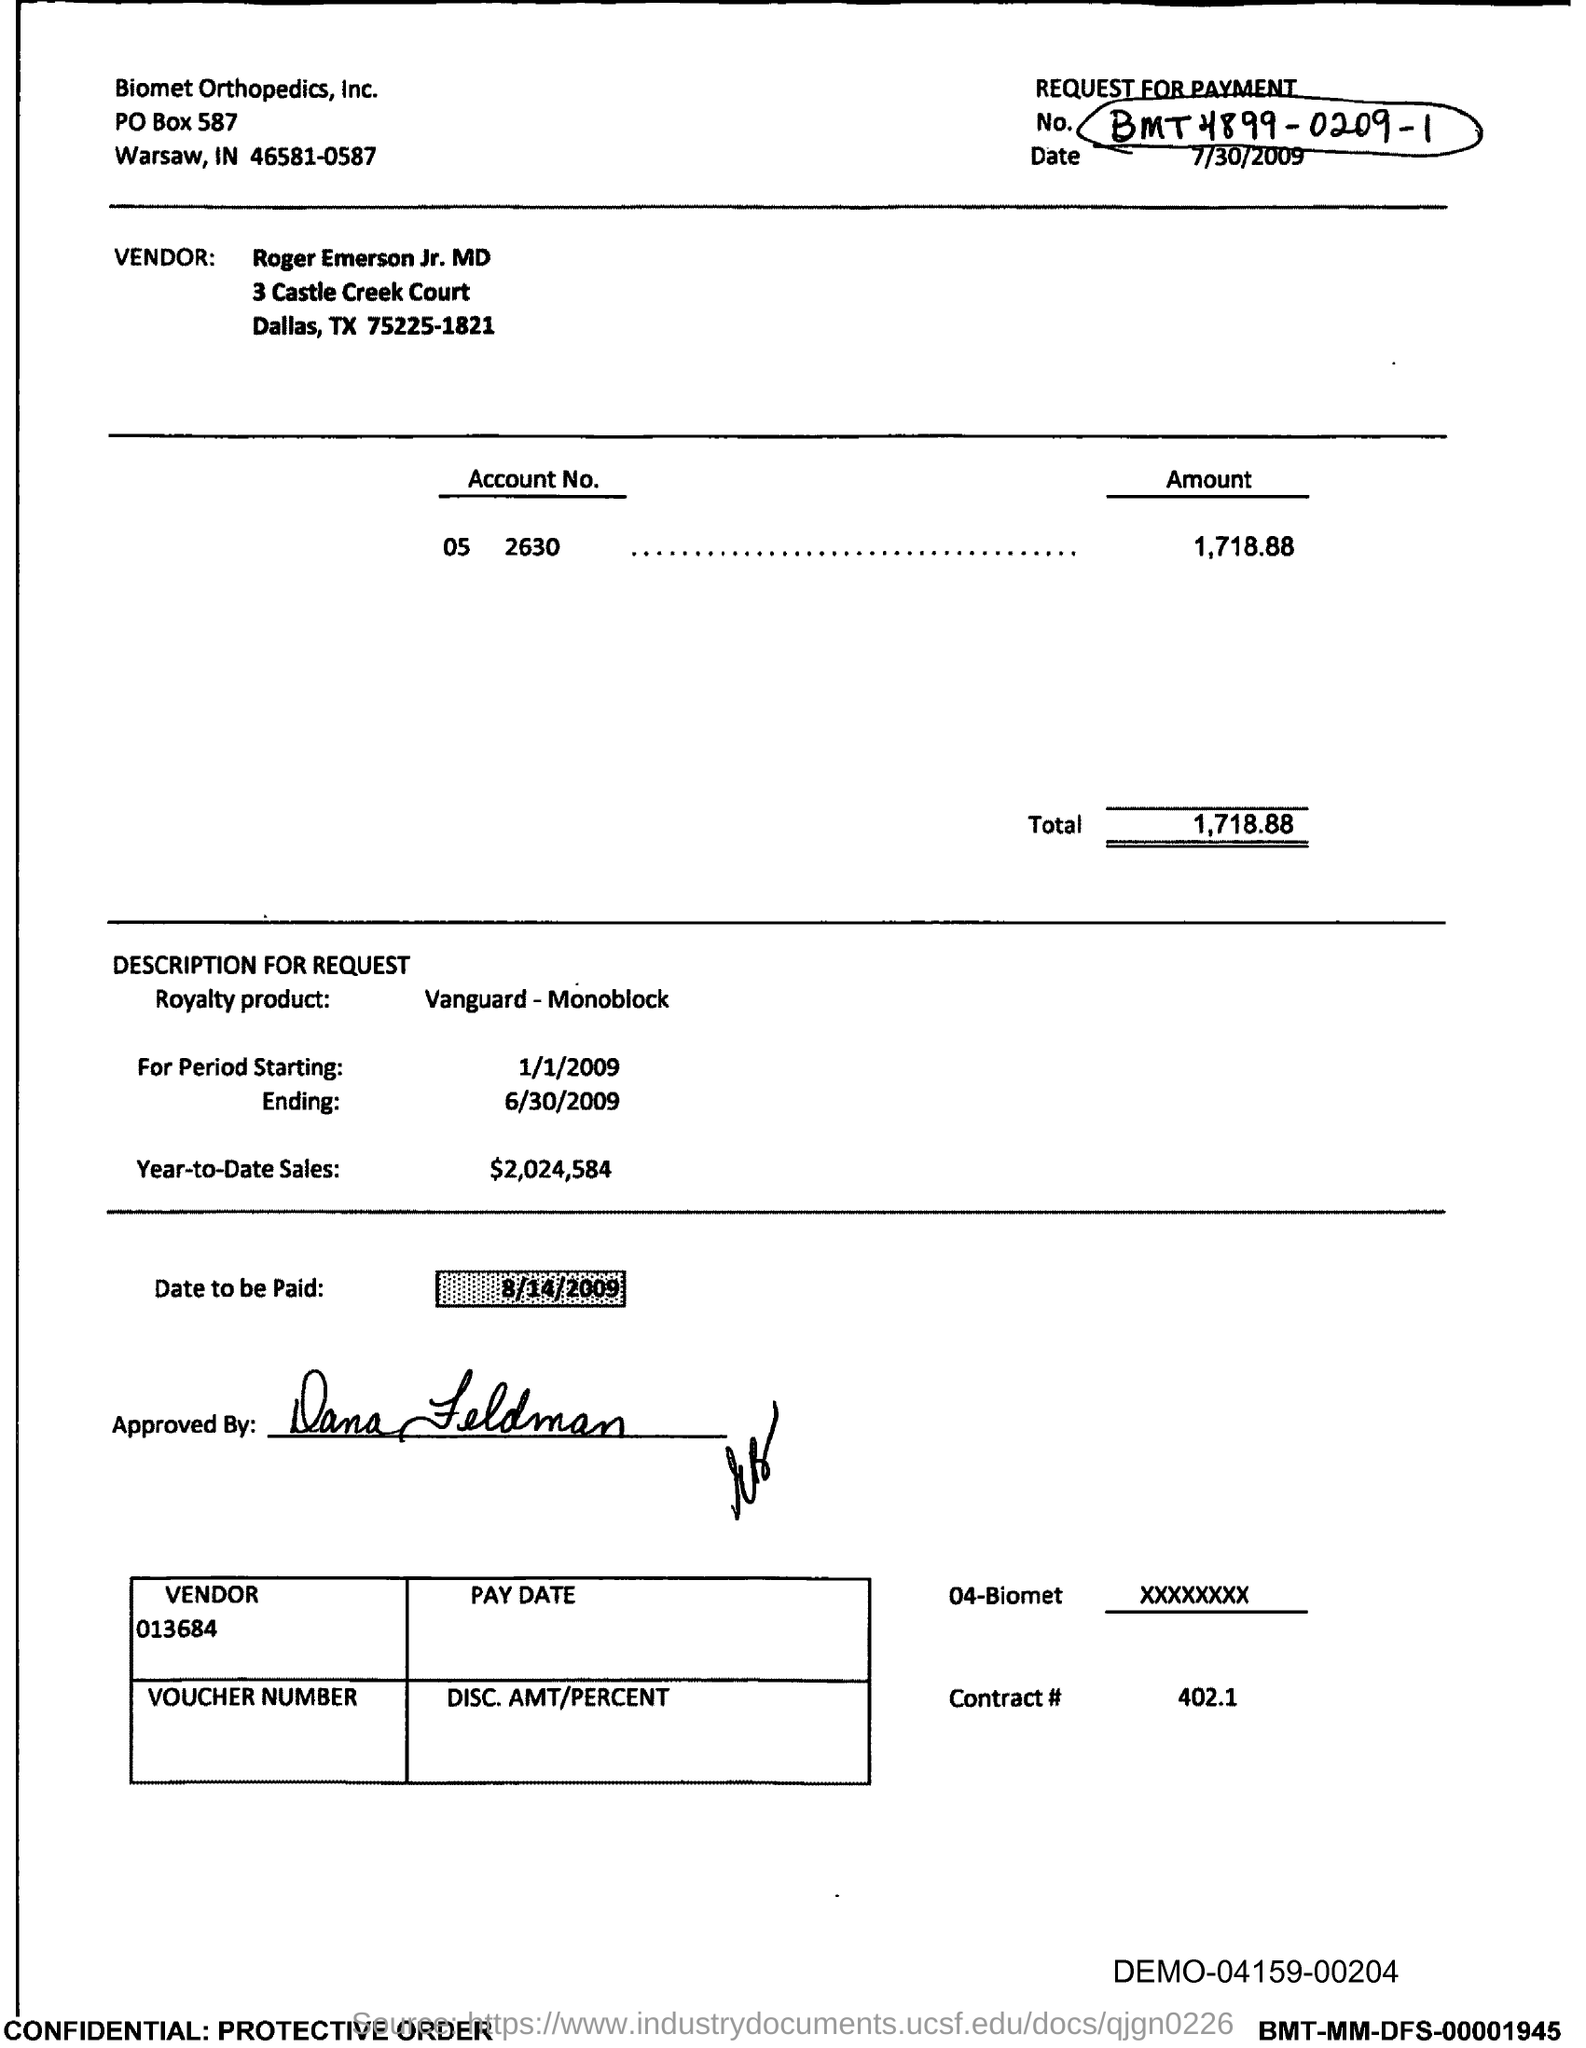Identify some key points in this picture. The year-to-date sales as of now are $2,024,584. The total is 1,718.88, rounded to the nearest cent. 